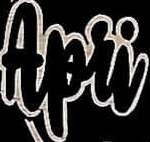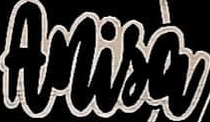What words can you see in these images in sequence, separated by a semicolon? Apri; Anisa 